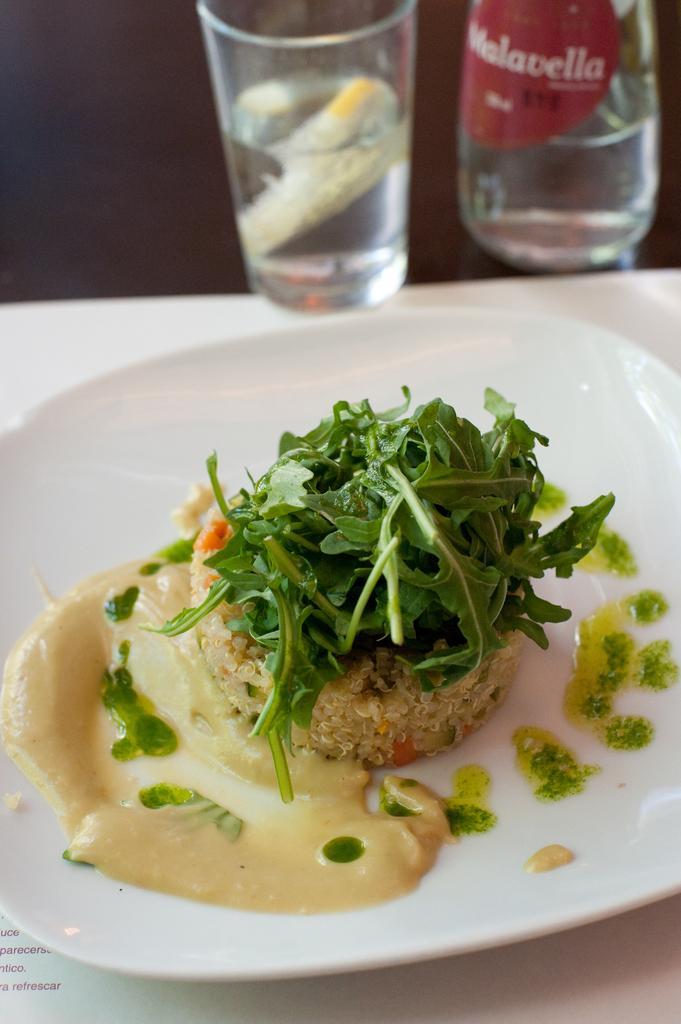In one or two sentences, can you explain what this image depicts? There is a plate, glasses on the table. On the plate there are some food items like leafy vegetables, cream and rice. 